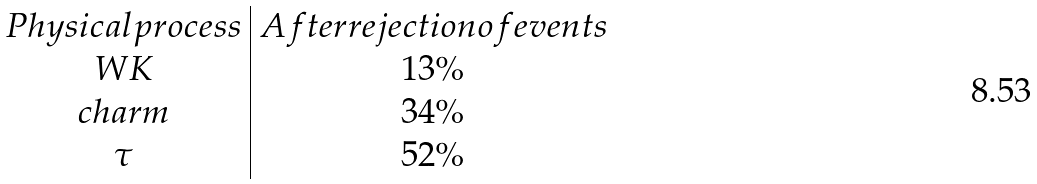Convert formula to latex. <formula><loc_0><loc_0><loc_500><loc_500>\begin{array} { c | c } P h y s i c a l p r o c e s s & A f t e r r e j e c t i o n o f e v e n t s \\ W K & 1 3 \% \\ c h a r m & 3 4 \% \\ \tau & 5 2 \% \\ \end{array}</formula> 